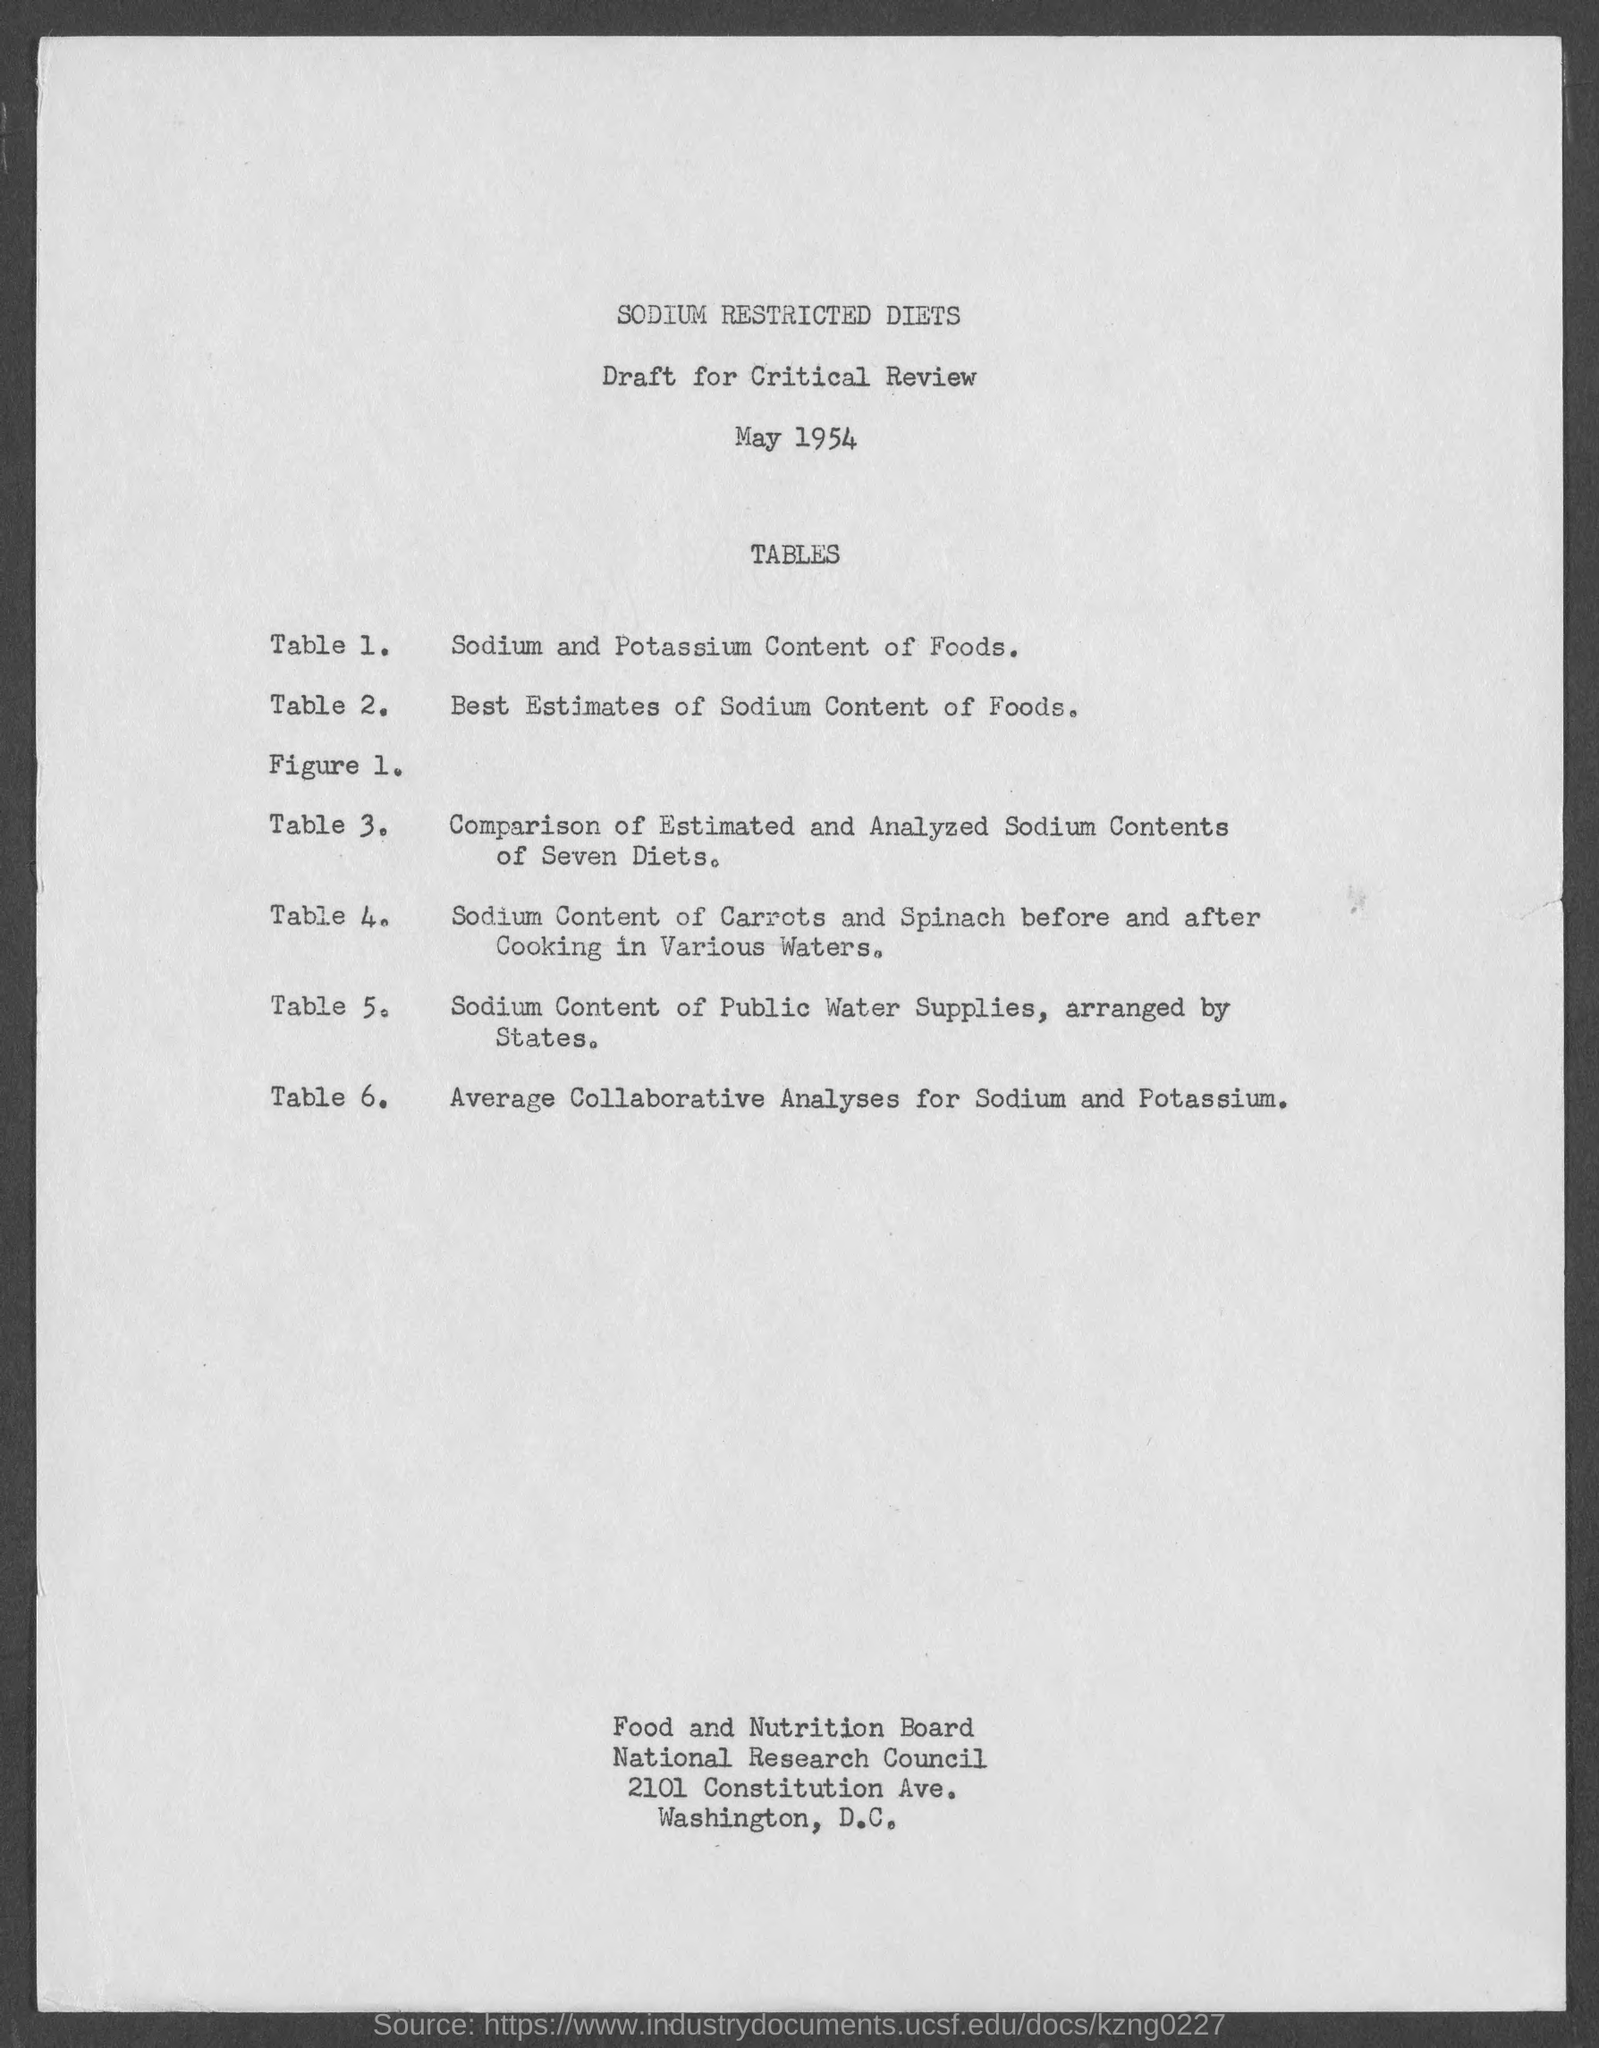What is the title of the document ?
Provide a succinct answer. SODIUM RESTRICTED DIETS. What is the title of table 1?
Keep it short and to the point. Sodium and Potassium Content of Foods. What is the title of table 2?
Your answer should be compact. Best Estimates of Sodium Content of Foods. What is the title of table 6?
Give a very brief answer. Average Collaborative Analyses for Sodium and Potassium. What is the street address of food and nutrition board ?
Your response must be concise. 2101 Constitution Ave. 